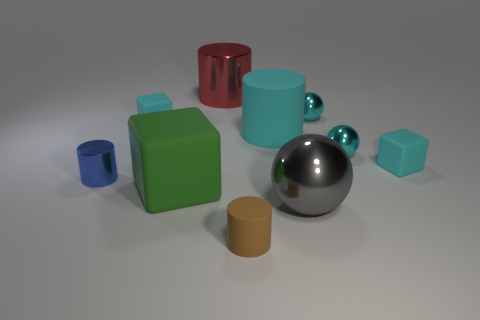What is the cylinder in front of the small metal cylinder made of? Based on the image, the cylinder in front of the small metal cylinder appears to have the qualities of plastic, characterized by its uniform color and matte surface finish. However, without physical examination, it's not possible to determine the material with certainty. 